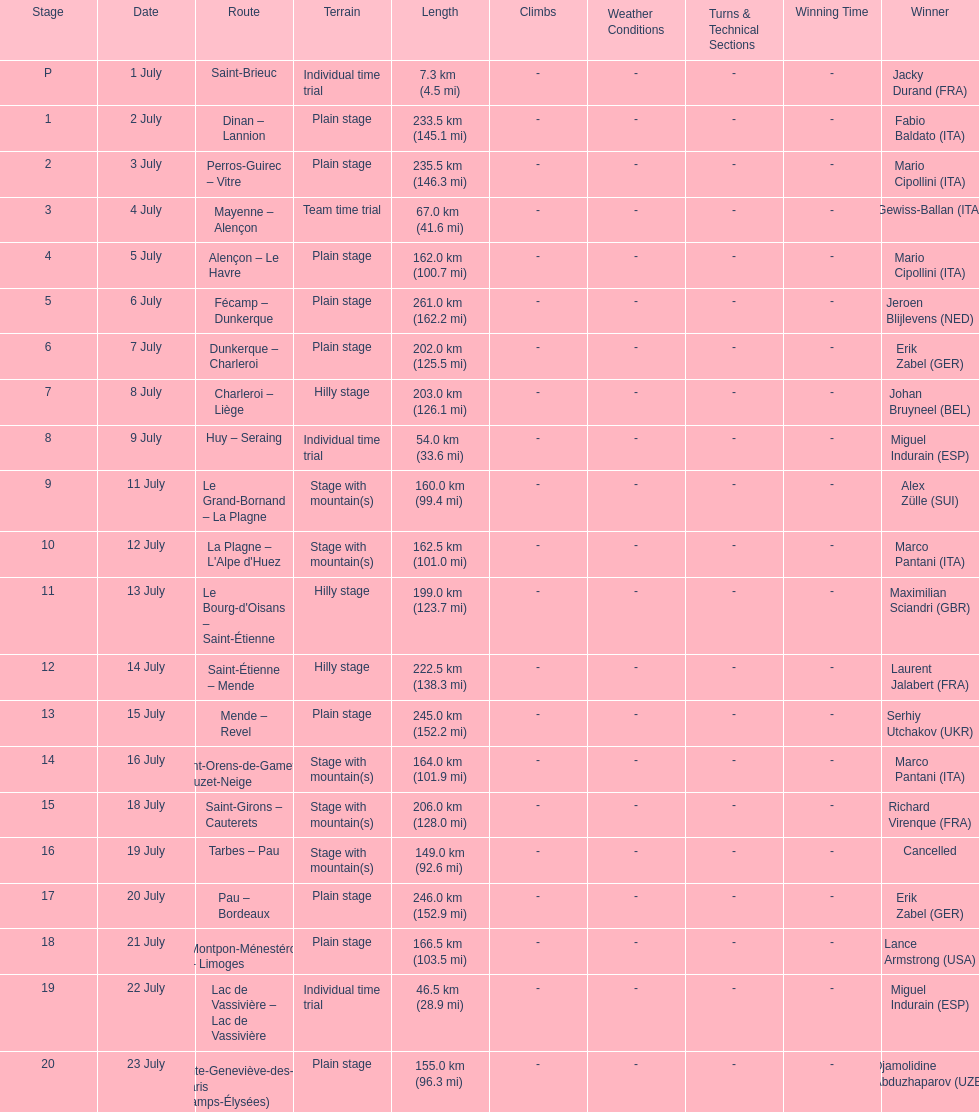How much longer is the 20th tour de france stage than the 19th? 108.5 km. 